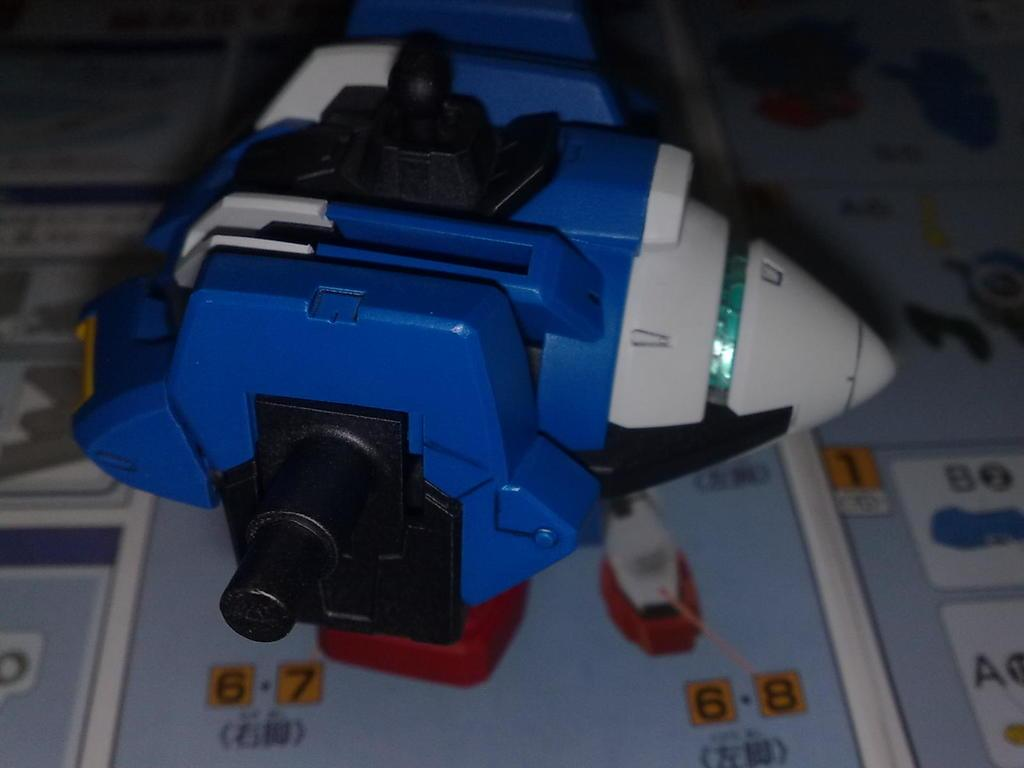What is the main structure in the image? There is a platform in the image. What can be found on the platform? Images and numbers are present on the platform, along with a toy. Can you describe the toy on the platform? The toy has black, white, and blue colors. How does the toy breathe in the image? The toy does not breathe in the image, as it is an inanimate object. 